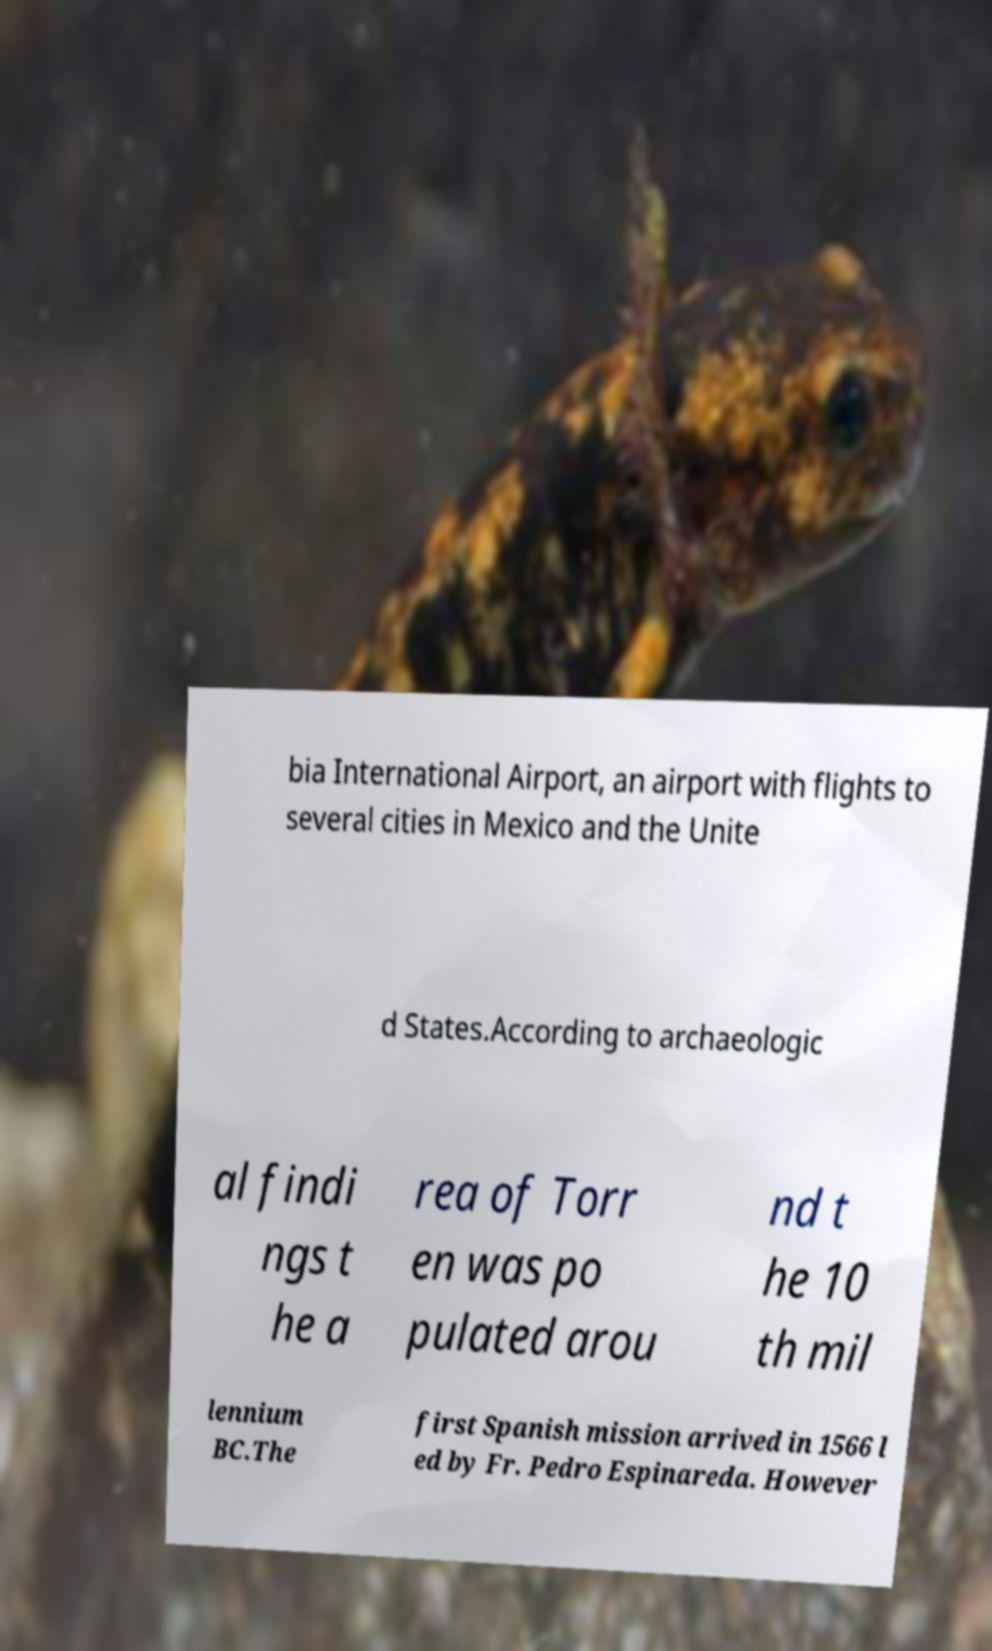There's text embedded in this image that I need extracted. Can you transcribe it verbatim? bia International Airport, an airport with flights to several cities in Mexico and the Unite d States.According to archaeologic al findi ngs t he a rea of Torr en was po pulated arou nd t he 10 th mil lennium BC.The first Spanish mission arrived in 1566 l ed by Fr. Pedro Espinareda. However 